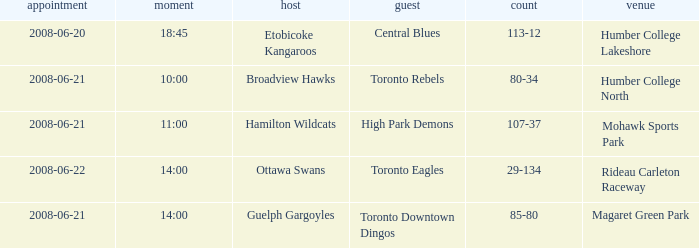What is the Away with a Ground that is humber college lakeshore? Central Blues. 